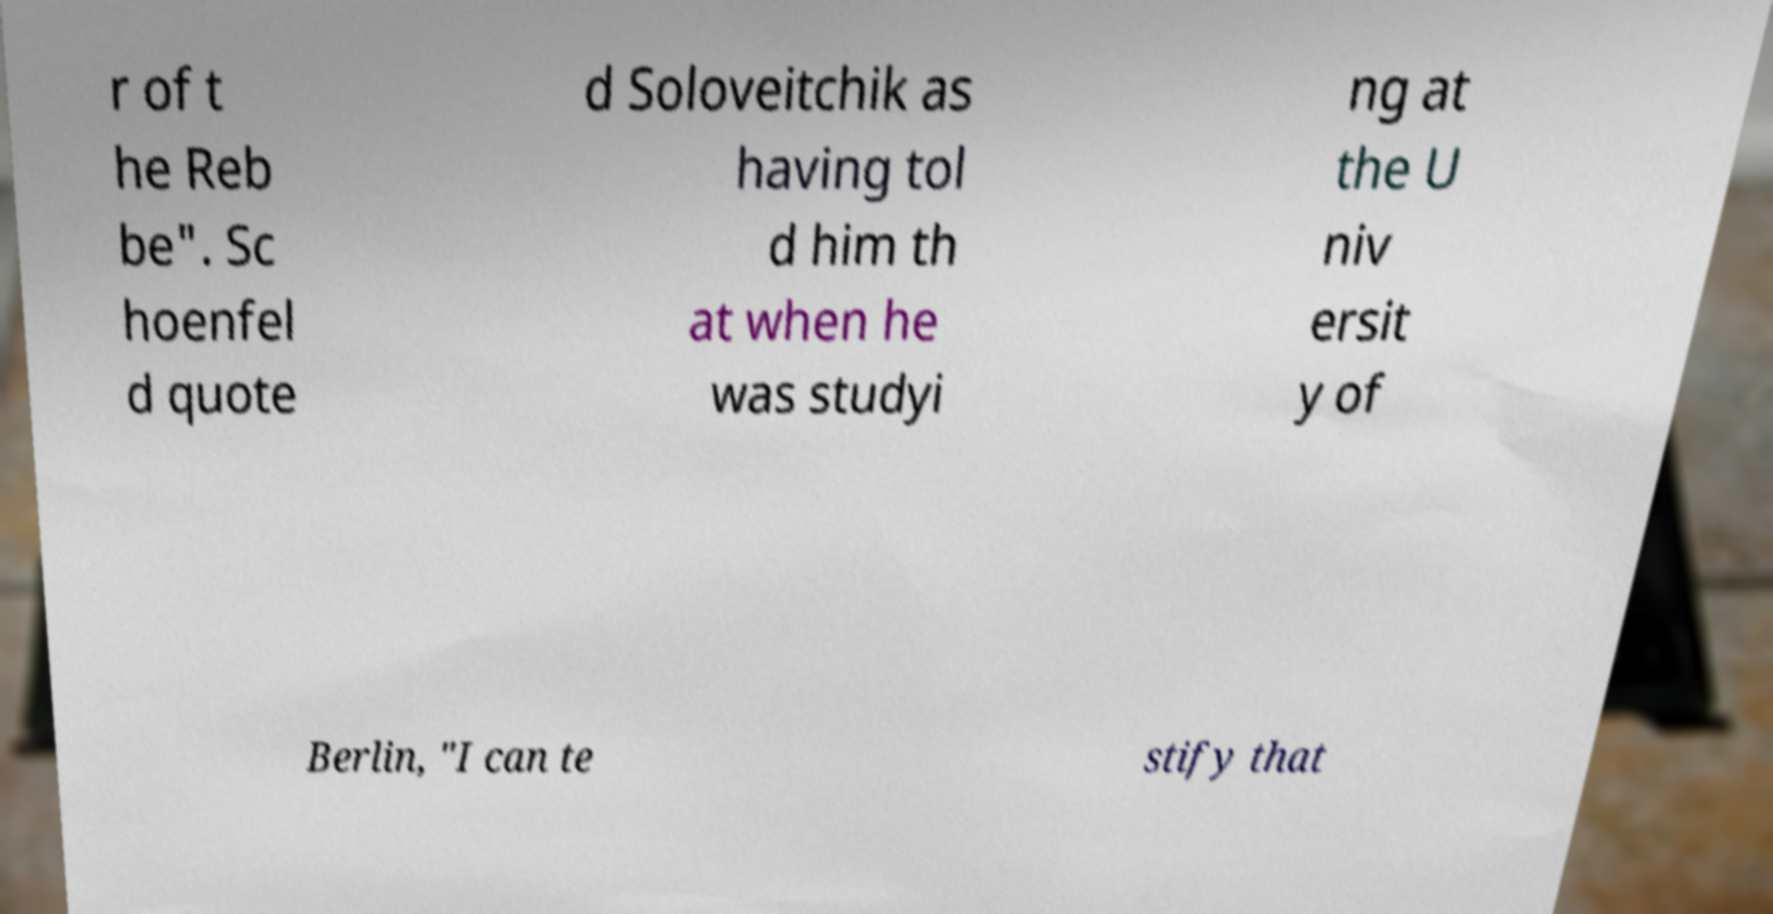For documentation purposes, I need the text within this image transcribed. Could you provide that? r of t he Reb be". Sc hoenfel d quote d Soloveitchik as having tol d him th at when he was studyi ng at the U niv ersit y of Berlin, "I can te stify that 